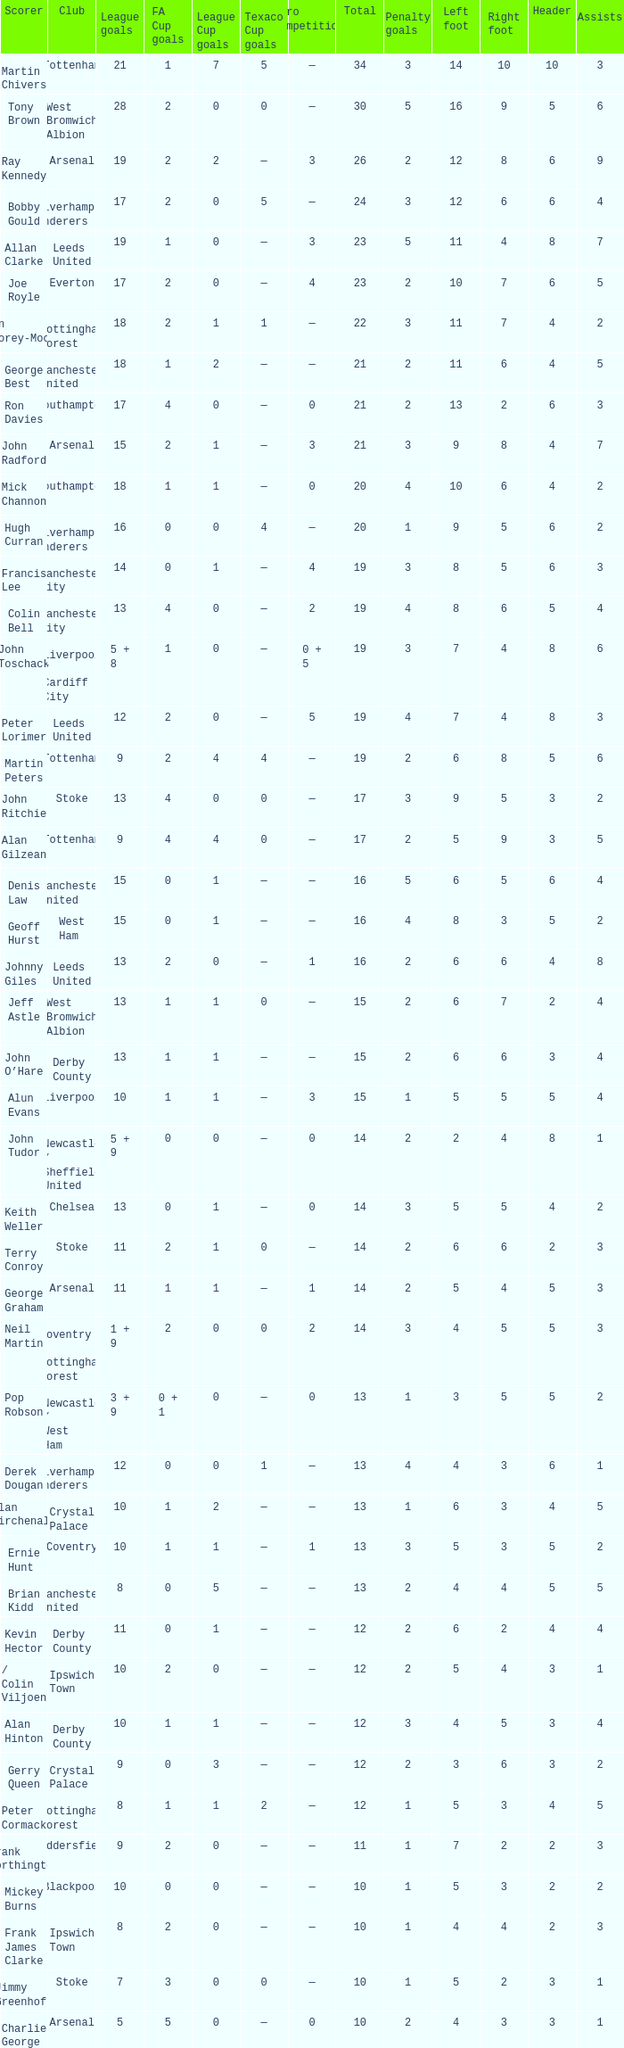What is the total number of Total, when Club is Leeds United, and when League Goals is 13? 1.0. 